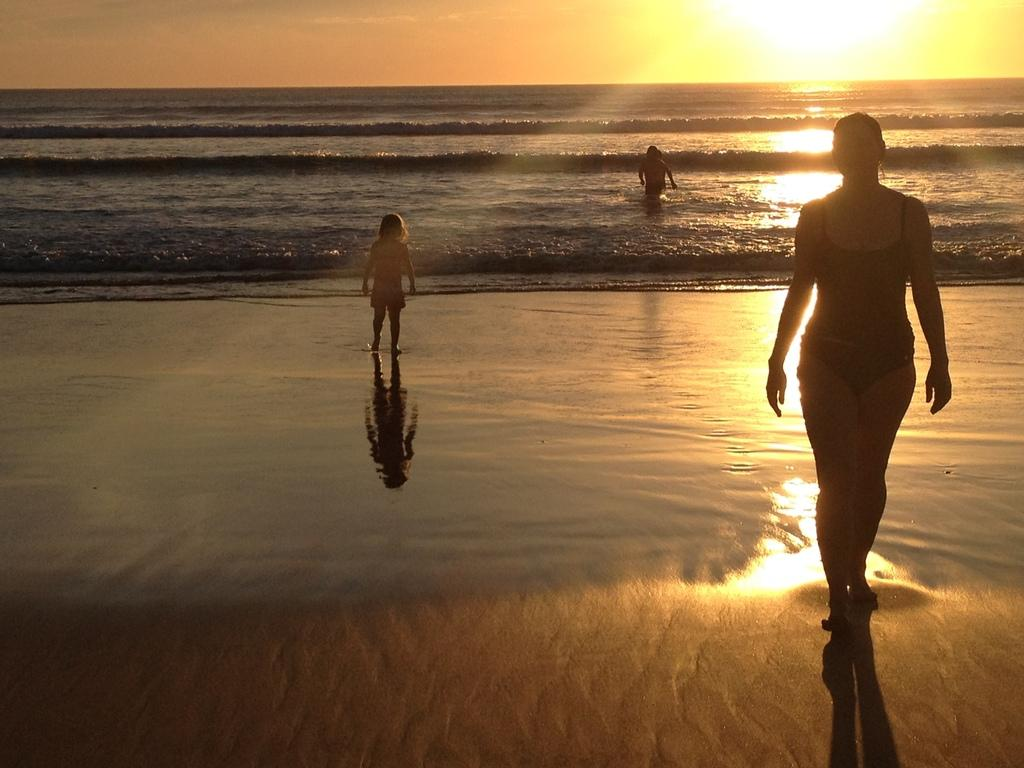Who or what is present in the image? There are people in the image. What is the setting of the image? The image features a sea shore at the bottom and the sea visible in the background. What can be seen in the sky in the image? The sky is visible in the image, and the sun is observable. Can you see a cactus being touched by a hammer in the image? There is no cactus or hammer present in the image. 